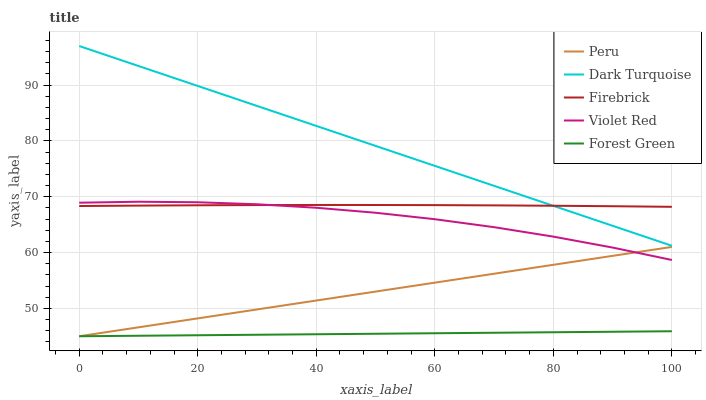Does Forest Green have the minimum area under the curve?
Answer yes or no. Yes. Does Dark Turquoise have the maximum area under the curve?
Answer yes or no. Yes. Does Firebrick have the minimum area under the curve?
Answer yes or no. No. Does Firebrick have the maximum area under the curve?
Answer yes or no. No. Is Dark Turquoise the smoothest?
Answer yes or no. Yes. Is Violet Red the roughest?
Answer yes or no. Yes. Is Firebrick the smoothest?
Answer yes or no. No. Is Firebrick the roughest?
Answer yes or no. No. Does Forest Green have the lowest value?
Answer yes or no. Yes. Does Dark Turquoise have the lowest value?
Answer yes or no. No. Does Dark Turquoise have the highest value?
Answer yes or no. Yes. Does Firebrick have the highest value?
Answer yes or no. No. Is Forest Green less than Violet Red?
Answer yes or no. Yes. Is Dark Turquoise greater than Forest Green?
Answer yes or no. Yes. Does Dark Turquoise intersect Firebrick?
Answer yes or no. Yes. Is Dark Turquoise less than Firebrick?
Answer yes or no. No. Is Dark Turquoise greater than Firebrick?
Answer yes or no. No. Does Forest Green intersect Violet Red?
Answer yes or no. No. 